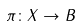Convert formula to latex. <formula><loc_0><loc_0><loc_500><loc_500>\pi \colon X \to B</formula> 